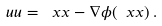Convert formula to latex. <formula><loc_0><loc_0><loc_500><loc_500>\ u u = \ x x - { \nabla } \phi ( \ x x ) \, .</formula> 